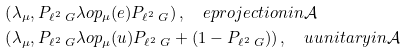Convert formula to latex. <formula><loc_0><loc_0><loc_500><loc_500>& \left ( \lambda _ { \mu } , P _ { \ell ^ { 2 } \ G } \lambda o p _ { \mu } ( e ) P _ { \ell ^ { 2 } \ G } \right ) , \quad e p r o j e c t i o n i n \mathcal { A } \\ & \left ( \lambda _ { \mu } , P _ { \ell ^ { 2 } \ G } \lambda o p _ { \mu } ( u ) P _ { \ell ^ { 2 } \ G } + ( 1 - P _ { \ell ^ { 2 } \ G } ) \right ) , \quad u u n i t a r y i n \mathcal { A }</formula> 